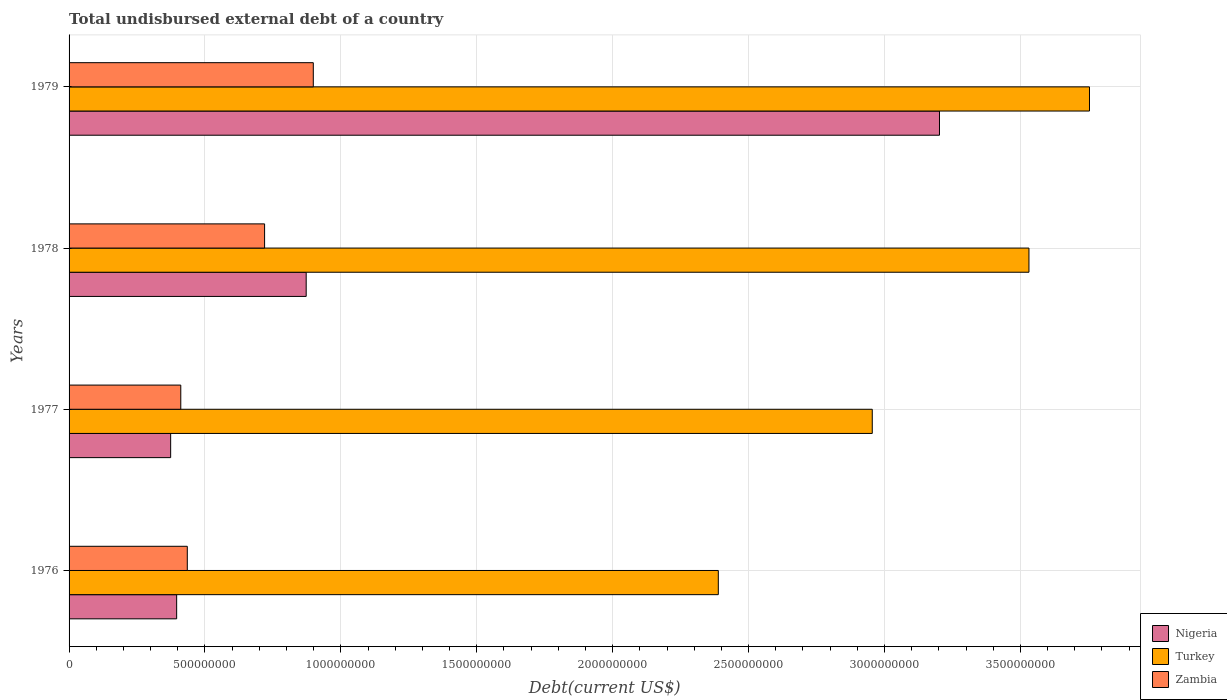How many different coloured bars are there?
Offer a terse response. 3. How many groups of bars are there?
Give a very brief answer. 4. Are the number of bars per tick equal to the number of legend labels?
Provide a short and direct response. Yes. Are the number of bars on each tick of the Y-axis equal?
Offer a terse response. Yes. How many bars are there on the 1st tick from the bottom?
Ensure brevity in your answer.  3. What is the label of the 4th group of bars from the top?
Provide a succinct answer. 1976. What is the total undisbursed external debt in Zambia in 1978?
Keep it short and to the point. 7.19e+08. Across all years, what is the maximum total undisbursed external debt in Nigeria?
Your answer should be compact. 3.20e+09. Across all years, what is the minimum total undisbursed external debt in Nigeria?
Make the answer very short. 3.74e+08. In which year was the total undisbursed external debt in Zambia maximum?
Your response must be concise. 1979. What is the total total undisbursed external debt in Zambia in the graph?
Ensure brevity in your answer.  2.46e+09. What is the difference between the total undisbursed external debt in Nigeria in 1976 and that in 1979?
Provide a succinct answer. -2.81e+09. What is the difference between the total undisbursed external debt in Zambia in 1978 and the total undisbursed external debt in Turkey in 1976?
Offer a terse response. -1.67e+09. What is the average total undisbursed external debt in Zambia per year?
Provide a succinct answer. 6.16e+08. In the year 1976, what is the difference between the total undisbursed external debt in Nigeria and total undisbursed external debt in Zambia?
Make the answer very short. -3.91e+07. In how many years, is the total undisbursed external debt in Turkey greater than 600000000 US$?
Provide a short and direct response. 4. What is the ratio of the total undisbursed external debt in Zambia in 1977 to that in 1979?
Provide a succinct answer. 0.46. Is the total undisbursed external debt in Nigeria in 1976 less than that in 1977?
Make the answer very short. No. What is the difference between the highest and the second highest total undisbursed external debt in Turkey?
Ensure brevity in your answer.  2.23e+08. What is the difference between the highest and the lowest total undisbursed external debt in Nigeria?
Keep it short and to the point. 2.83e+09. In how many years, is the total undisbursed external debt in Zambia greater than the average total undisbursed external debt in Zambia taken over all years?
Offer a terse response. 2. Is the sum of the total undisbursed external debt in Zambia in 1976 and 1978 greater than the maximum total undisbursed external debt in Nigeria across all years?
Your answer should be compact. No. What does the 3rd bar from the top in 1976 represents?
Ensure brevity in your answer.  Nigeria. What does the 1st bar from the bottom in 1977 represents?
Your response must be concise. Nigeria. Are all the bars in the graph horizontal?
Provide a succinct answer. Yes. What is the difference between two consecutive major ticks on the X-axis?
Offer a very short reply. 5.00e+08. Are the values on the major ticks of X-axis written in scientific E-notation?
Offer a very short reply. No. Does the graph contain grids?
Your response must be concise. Yes. How many legend labels are there?
Offer a very short reply. 3. How are the legend labels stacked?
Ensure brevity in your answer.  Vertical. What is the title of the graph?
Your answer should be compact. Total undisbursed external debt of a country. What is the label or title of the X-axis?
Offer a terse response. Debt(current US$). What is the label or title of the Y-axis?
Provide a succinct answer. Years. What is the Debt(current US$) of Nigeria in 1976?
Give a very brief answer. 3.96e+08. What is the Debt(current US$) in Turkey in 1976?
Give a very brief answer. 2.39e+09. What is the Debt(current US$) of Zambia in 1976?
Your answer should be compact. 4.35e+08. What is the Debt(current US$) in Nigeria in 1977?
Your response must be concise. 3.74e+08. What is the Debt(current US$) in Turkey in 1977?
Keep it short and to the point. 2.95e+09. What is the Debt(current US$) in Zambia in 1977?
Provide a short and direct response. 4.11e+08. What is the Debt(current US$) of Nigeria in 1978?
Give a very brief answer. 8.72e+08. What is the Debt(current US$) of Turkey in 1978?
Make the answer very short. 3.53e+09. What is the Debt(current US$) of Zambia in 1978?
Ensure brevity in your answer.  7.19e+08. What is the Debt(current US$) of Nigeria in 1979?
Your response must be concise. 3.20e+09. What is the Debt(current US$) of Turkey in 1979?
Offer a terse response. 3.75e+09. What is the Debt(current US$) in Zambia in 1979?
Ensure brevity in your answer.  8.99e+08. Across all years, what is the maximum Debt(current US$) of Nigeria?
Ensure brevity in your answer.  3.20e+09. Across all years, what is the maximum Debt(current US$) of Turkey?
Give a very brief answer. 3.75e+09. Across all years, what is the maximum Debt(current US$) in Zambia?
Offer a terse response. 8.99e+08. Across all years, what is the minimum Debt(current US$) of Nigeria?
Give a very brief answer. 3.74e+08. Across all years, what is the minimum Debt(current US$) of Turkey?
Your answer should be compact. 2.39e+09. Across all years, what is the minimum Debt(current US$) of Zambia?
Offer a terse response. 4.11e+08. What is the total Debt(current US$) of Nigeria in the graph?
Ensure brevity in your answer.  4.84e+09. What is the total Debt(current US$) of Turkey in the graph?
Your response must be concise. 1.26e+1. What is the total Debt(current US$) in Zambia in the graph?
Give a very brief answer. 2.46e+09. What is the difference between the Debt(current US$) in Nigeria in 1976 and that in 1977?
Provide a succinct answer. 2.21e+07. What is the difference between the Debt(current US$) of Turkey in 1976 and that in 1977?
Ensure brevity in your answer.  -5.66e+08. What is the difference between the Debt(current US$) in Zambia in 1976 and that in 1977?
Give a very brief answer. 2.40e+07. What is the difference between the Debt(current US$) in Nigeria in 1976 and that in 1978?
Provide a short and direct response. -4.77e+08. What is the difference between the Debt(current US$) in Turkey in 1976 and that in 1978?
Keep it short and to the point. -1.14e+09. What is the difference between the Debt(current US$) of Zambia in 1976 and that in 1978?
Offer a terse response. -2.84e+08. What is the difference between the Debt(current US$) of Nigeria in 1976 and that in 1979?
Your answer should be compact. -2.81e+09. What is the difference between the Debt(current US$) in Turkey in 1976 and that in 1979?
Your response must be concise. -1.37e+09. What is the difference between the Debt(current US$) of Zambia in 1976 and that in 1979?
Offer a very short reply. -4.64e+08. What is the difference between the Debt(current US$) in Nigeria in 1977 and that in 1978?
Your response must be concise. -4.99e+08. What is the difference between the Debt(current US$) in Turkey in 1977 and that in 1978?
Give a very brief answer. -5.76e+08. What is the difference between the Debt(current US$) of Zambia in 1977 and that in 1978?
Keep it short and to the point. -3.08e+08. What is the difference between the Debt(current US$) of Nigeria in 1977 and that in 1979?
Your response must be concise. -2.83e+09. What is the difference between the Debt(current US$) of Turkey in 1977 and that in 1979?
Provide a succinct answer. -7.99e+08. What is the difference between the Debt(current US$) of Zambia in 1977 and that in 1979?
Offer a very short reply. -4.88e+08. What is the difference between the Debt(current US$) of Nigeria in 1978 and that in 1979?
Offer a very short reply. -2.33e+09. What is the difference between the Debt(current US$) of Turkey in 1978 and that in 1979?
Ensure brevity in your answer.  -2.23e+08. What is the difference between the Debt(current US$) of Zambia in 1978 and that in 1979?
Ensure brevity in your answer.  -1.79e+08. What is the difference between the Debt(current US$) of Nigeria in 1976 and the Debt(current US$) of Turkey in 1977?
Offer a terse response. -2.56e+09. What is the difference between the Debt(current US$) of Nigeria in 1976 and the Debt(current US$) of Zambia in 1977?
Give a very brief answer. -1.52e+07. What is the difference between the Debt(current US$) in Turkey in 1976 and the Debt(current US$) in Zambia in 1977?
Provide a succinct answer. 1.98e+09. What is the difference between the Debt(current US$) of Nigeria in 1976 and the Debt(current US$) of Turkey in 1978?
Your response must be concise. -3.14e+09. What is the difference between the Debt(current US$) of Nigeria in 1976 and the Debt(current US$) of Zambia in 1978?
Give a very brief answer. -3.24e+08. What is the difference between the Debt(current US$) in Turkey in 1976 and the Debt(current US$) in Zambia in 1978?
Keep it short and to the point. 1.67e+09. What is the difference between the Debt(current US$) in Nigeria in 1976 and the Debt(current US$) in Turkey in 1979?
Your response must be concise. -3.36e+09. What is the difference between the Debt(current US$) in Nigeria in 1976 and the Debt(current US$) in Zambia in 1979?
Give a very brief answer. -5.03e+08. What is the difference between the Debt(current US$) of Turkey in 1976 and the Debt(current US$) of Zambia in 1979?
Provide a short and direct response. 1.49e+09. What is the difference between the Debt(current US$) of Nigeria in 1977 and the Debt(current US$) of Turkey in 1978?
Give a very brief answer. -3.16e+09. What is the difference between the Debt(current US$) of Nigeria in 1977 and the Debt(current US$) of Zambia in 1978?
Provide a short and direct response. -3.46e+08. What is the difference between the Debt(current US$) in Turkey in 1977 and the Debt(current US$) in Zambia in 1978?
Provide a short and direct response. 2.24e+09. What is the difference between the Debt(current US$) of Nigeria in 1977 and the Debt(current US$) of Turkey in 1979?
Provide a short and direct response. -3.38e+09. What is the difference between the Debt(current US$) in Nigeria in 1977 and the Debt(current US$) in Zambia in 1979?
Offer a terse response. -5.25e+08. What is the difference between the Debt(current US$) in Turkey in 1977 and the Debt(current US$) in Zambia in 1979?
Offer a terse response. 2.06e+09. What is the difference between the Debt(current US$) in Nigeria in 1978 and the Debt(current US$) in Turkey in 1979?
Offer a very short reply. -2.88e+09. What is the difference between the Debt(current US$) in Nigeria in 1978 and the Debt(current US$) in Zambia in 1979?
Offer a terse response. -2.61e+07. What is the difference between the Debt(current US$) of Turkey in 1978 and the Debt(current US$) of Zambia in 1979?
Provide a succinct answer. 2.63e+09. What is the average Debt(current US$) in Nigeria per year?
Keep it short and to the point. 1.21e+09. What is the average Debt(current US$) of Turkey per year?
Give a very brief answer. 3.16e+09. What is the average Debt(current US$) of Zambia per year?
Offer a terse response. 6.16e+08. In the year 1976, what is the difference between the Debt(current US$) in Nigeria and Debt(current US$) in Turkey?
Offer a terse response. -1.99e+09. In the year 1976, what is the difference between the Debt(current US$) of Nigeria and Debt(current US$) of Zambia?
Your response must be concise. -3.91e+07. In the year 1976, what is the difference between the Debt(current US$) in Turkey and Debt(current US$) in Zambia?
Ensure brevity in your answer.  1.95e+09. In the year 1977, what is the difference between the Debt(current US$) in Nigeria and Debt(current US$) in Turkey?
Provide a short and direct response. -2.58e+09. In the year 1977, what is the difference between the Debt(current US$) of Nigeria and Debt(current US$) of Zambia?
Offer a very short reply. -3.72e+07. In the year 1977, what is the difference between the Debt(current US$) in Turkey and Debt(current US$) in Zambia?
Your answer should be very brief. 2.54e+09. In the year 1978, what is the difference between the Debt(current US$) in Nigeria and Debt(current US$) in Turkey?
Keep it short and to the point. -2.66e+09. In the year 1978, what is the difference between the Debt(current US$) of Nigeria and Debt(current US$) of Zambia?
Keep it short and to the point. 1.53e+08. In the year 1978, what is the difference between the Debt(current US$) of Turkey and Debt(current US$) of Zambia?
Give a very brief answer. 2.81e+09. In the year 1979, what is the difference between the Debt(current US$) in Nigeria and Debt(current US$) in Turkey?
Give a very brief answer. -5.52e+08. In the year 1979, what is the difference between the Debt(current US$) in Nigeria and Debt(current US$) in Zambia?
Offer a terse response. 2.30e+09. In the year 1979, what is the difference between the Debt(current US$) in Turkey and Debt(current US$) in Zambia?
Your response must be concise. 2.86e+09. What is the ratio of the Debt(current US$) in Nigeria in 1976 to that in 1977?
Provide a short and direct response. 1.06. What is the ratio of the Debt(current US$) of Turkey in 1976 to that in 1977?
Give a very brief answer. 0.81. What is the ratio of the Debt(current US$) in Zambia in 1976 to that in 1977?
Provide a succinct answer. 1.06. What is the ratio of the Debt(current US$) of Nigeria in 1976 to that in 1978?
Offer a terse response. 0.45. What is the ratio of the Debt(current US$) in Turkey in 1976 to that in 1978?
Your answer should be compact. 0.68. What is the ratio of the Debt(current US$) in Zambia in 1976 to that in 1978?
Ensure brevity in your answer.  0.6. What is the ratio of the Debt(current US$) of Nigeria in 1976 to that in 1979?
Your response must be concise. 0.12. What is the ratio of the Debt(current US$) in Turkey in 1976 to that in 1979?
Provide a short and direct response. 0.64. What is the ratio of the Debt(current US$) in Zambia in 1976 to that in 1979?
Make the answer very short. 0.48. What is the ratio of the Debt(current US$) in Nigeria in 1977 to that in 1978?
Provide a succinct answer. 0.43. What is the ratio of the Debt(current US$) of Turkey in 1977 to that in 1978?
Make the answer very short. 0.84. What is the ratio of the Debt(current US$) of Zambia in 1977 to that in 1978?
Your answer should be very brief. 0.57. What is the ratio of the Debt(current US$) of Nigeria in 1977 to that in 1979?
Give a very brief answer. 0.12. What is the ratio of the Debt(current US$) of Turkey in 1977 to that in 1979?
Your answer should be very brief. 0.79. What is the ratio of the Debt(current US$) in Zambia in 1977 to that in 1979?
Your response must be concise. 0.46. What is the ratio of the Debt(current US$) in Nigeria in 1978 to that in 1979?
Offer a very short reply. 0.27. What is the ratio of the Debt(current US$) of Turkey in 1978 to that in 1979?
Ensure brevity in your answer.  0.94. What is the ratio of the Debt(current US$) of Zambia in 1978 to that in 1979?
Make the answer very short. 0.8. What is the difference between the highest and the second highest Debt(current US$) in Nigeria?
Your response must be concise. 2.33e+09. What is the difference between the highest and the second highest Debt(current US$) in Turkey?
Provide a short and direct response. 2.23e+08. What is the difference between the highest and the second highest Debt(current US$) of Zambia?
Provide a short and direct response. 1.79e+08. What is the difference between the highest and the lowest Debt(current US$) of Nigeria?
Your answer should be very brief. 2.83e+09. What is the difference between the highest and the lowest Debt(current US$) of Turkey?
Make the answer very short. 1.37e+09. What is the difference between the highest and the lowest Debt(current US$) in Zambia?
Give a very brief answer. 4.88e+08. 